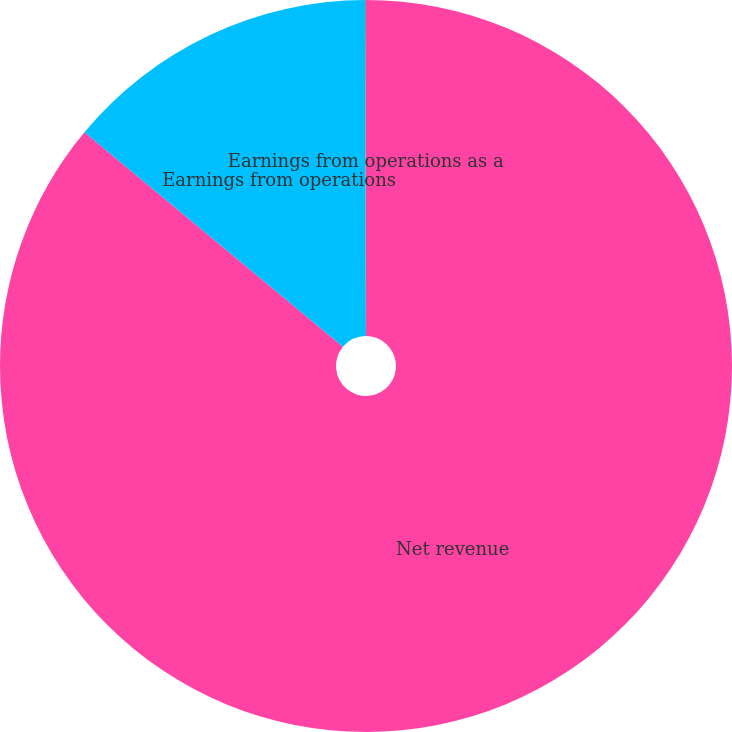Convert chart. <chart><loc_0><loc_0><loc_500><loc_500><pie_chart><fcel>Net revenue<fcel>Earnings from operations<fcel>Earnings from operations as a<nl><fcel>86.03%<fcel>13.93%<fcel>0.04%<nl></chart> 